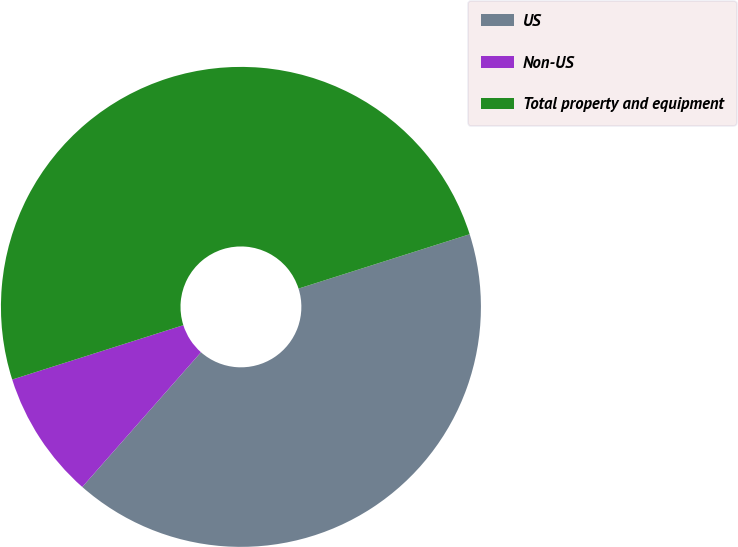<chart> <loc_0><loc_0><loc_500><loc_500><pie_chart><fcel>US<fcel>Non-US<fcel>Total property and equipment<nl><fcel>41.39%<fcel>8.61%<fcel>50.0%<nl></chart> 